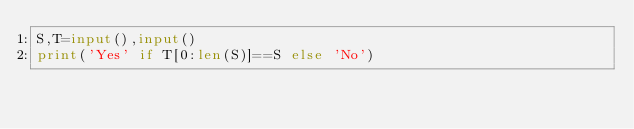Convert code to text. <code><loc_0><loc_0><loc_500><loc_500><_Python_>S,T=input(),input()
print('Yes' if T[0:len(S)]==S else 'No')</code> 